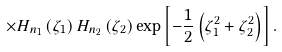<formula> <loc_0><loc_0><loc_500><loc_500>\times H _ { n _ { 1 } } \left ( \zeta _ { 1 } \right ) H _ { n _ { 2 } } \left ( \zeta _ { 2 } \right ) \exp \left [ - \frac { 1 } { 2 } \left ( \zeta _ { 1 } ^ { 2 } + \zeta _ { 2 } ^ { 2 } \right ) \right ] .</formula> 